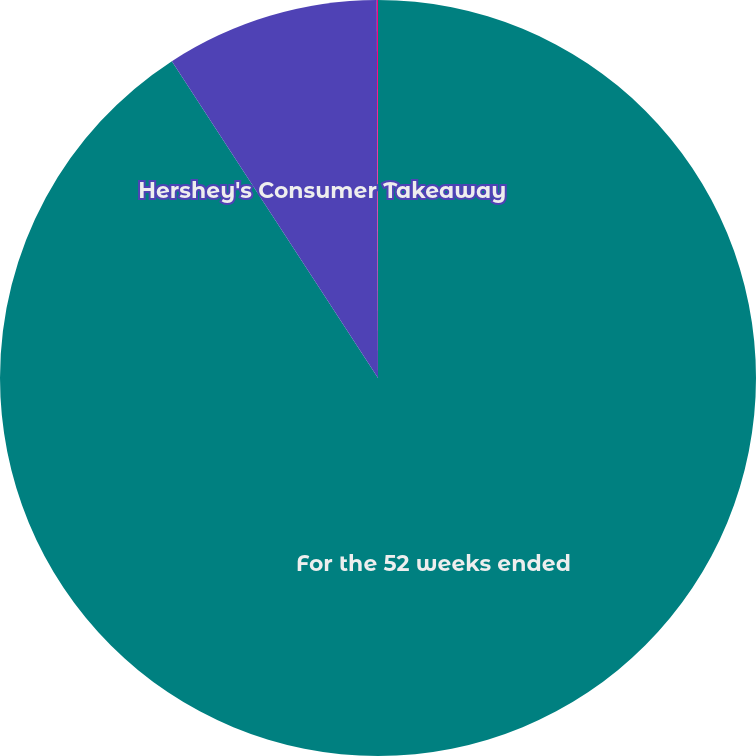Convert chart. <chart><loc_0><loc_0><loc_500><loc_500><pie_chart><fcel>For the 52 weeks ended<fcel>Hershey's Consumer Takeaway<fcel>Hershey's Market Share<nl><fcel>90.82%<fcel>9.13%<fcel>0.05%<nl></chart> 